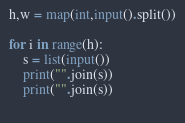Convert code to text. <code><loc_0><loc_0><loc_500><loc_500><_Python_>h,w = map(int,input().split())

for i in range(h):
    s = list(input())
    print("".join(s))
    print("".join(s))
    </code> 